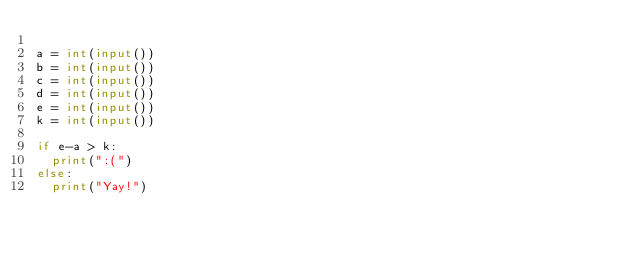Convert code to text. <code><loc_0><loc_0><loc_500><loc_500><_Python_>
a = int(input())
b = int(input())
c = int(input())
d = int(input())
e = int(input())
k = int(input())

if e-a > k:
  print(":(")
else:
  print("Yay!")
</code> 